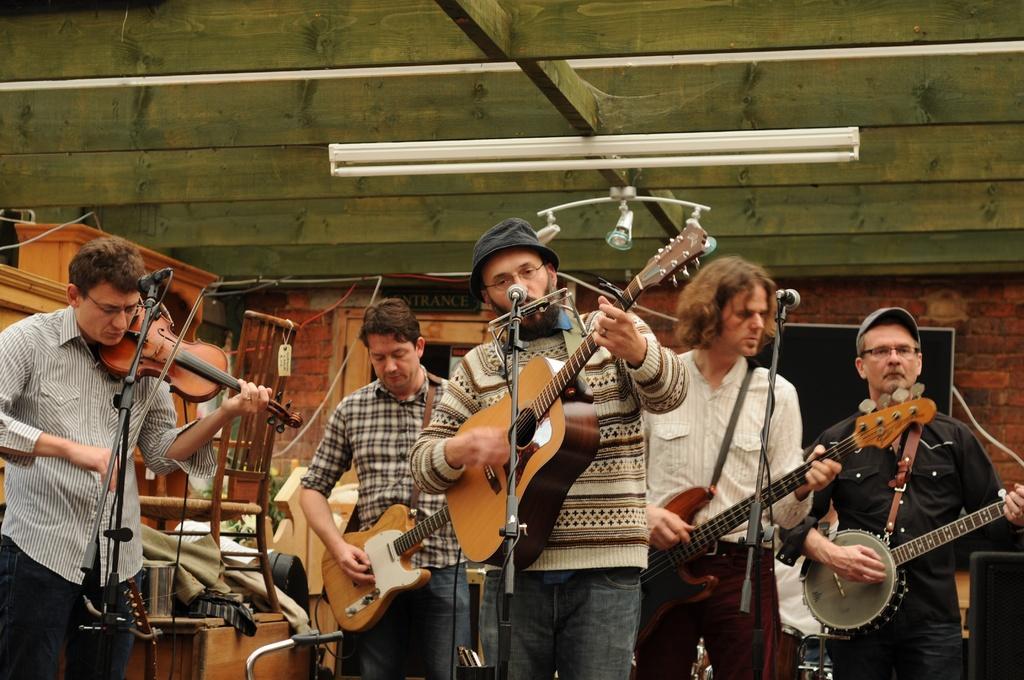How would you summarize this image in a sentence or two? In this picture there is a music band here. All of them were playing guitars and some of them was playing violin. Everybody is having a microphone in front of them. In the background there is a light here. 